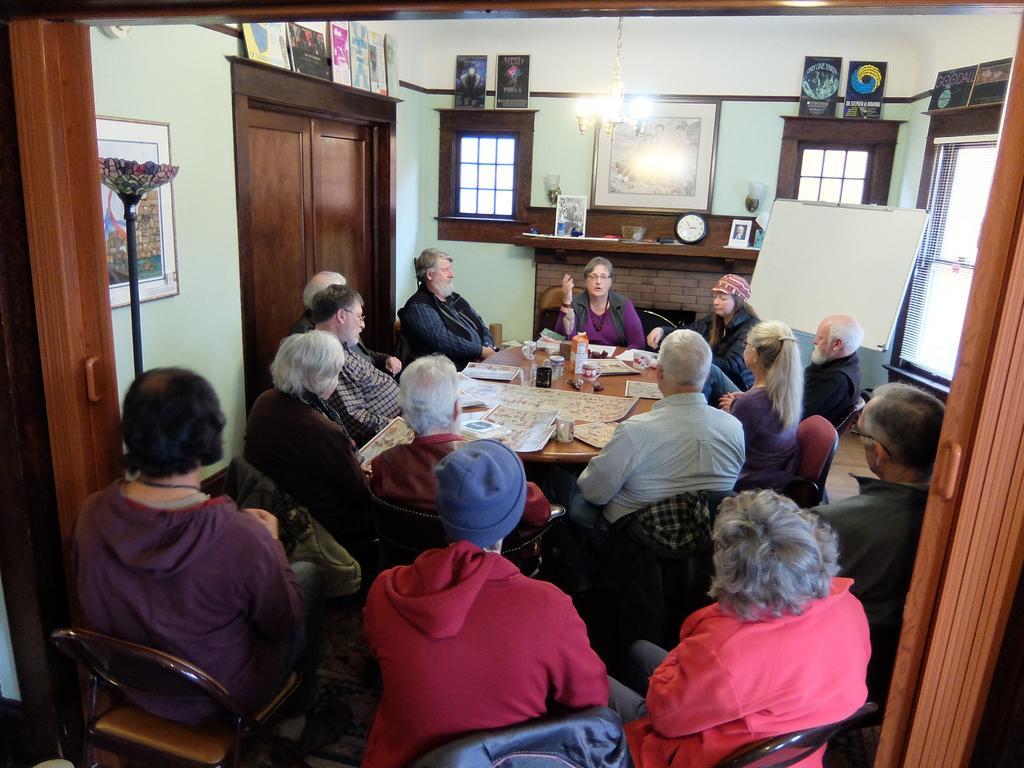Please provide a concise description of this image. In the picture we can see a set of people sitting on the chairs near the table and some people are sitting in the backside of some people who are sitting on chairs. In the background we can see a wall with wooden doors, windows, a table. On the table we can see a photo frame with same clock, pictures and light. 